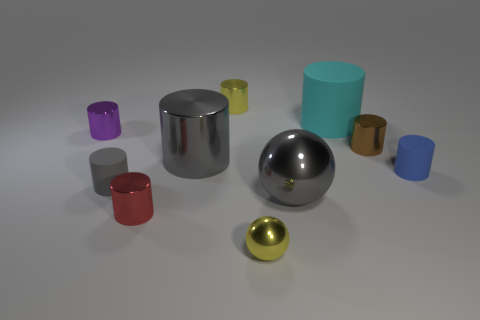Subtract all purple cylinders. How many cylinders are left? 7 Subtract all cyan cylinders. How many cylinders are left? 7 Subtract all purple spheres. Subtract all gray cubes. How many spheres are left? 2 Subtract all spheres. How many objects are left? 8 Subtract all small red cylinders. Subtract all red metal cylinders. How many objects are left? 8 Add 9 small balls. How many small balls are left? 10 Add 7 purple cylinders. How many purple cylinders exist? 8 Subtract 1 gray balls. How many objects are left? 9 